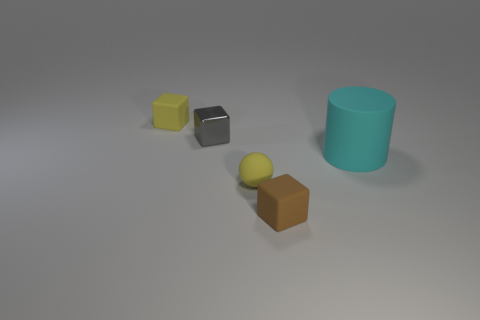There is a object that is both in front of the gray shiny object and to the left of the small brown cube; what is its size?
Your answer should be compact. Small. There is a ball that is the same size as the gray metal object; what color is it?
Ensure brevity in your answer.  Yellow. There is another rubber thing that is the same shape as the brown object; what color is it?
Keep it short and to the point. Yellow. There is a yellow object in front of the small rubber cube that is to the left of the block that is on the right side of the metal cube; how big is it?
Provide a short and direct response. Small. What is the color of the small thing that is behind the brown matte object and on the right side of the gray metal cube?
Offer a terse response. Yellow. Do the yellow ball and the yellow cube have the same material?
Offer a terse response. Yes. There is a rubber thing that is left of the tiny metallic block; is its size the same as the thing that is in front of the matte sphere?
Give a very brief answer. Yes. Are there any objects that are to the right of the cyan matte cylinder that is behind the tiny brown matte cube?
Keep it short and to the point. No. Is the big cyan cylinder behind the tiny brown object made of the same material as the small brown object?
Ensure brevity in your answer.  Yes. How many other objects are there of the same color as the tiny metallic object?
Your answer should be compact. 0. 